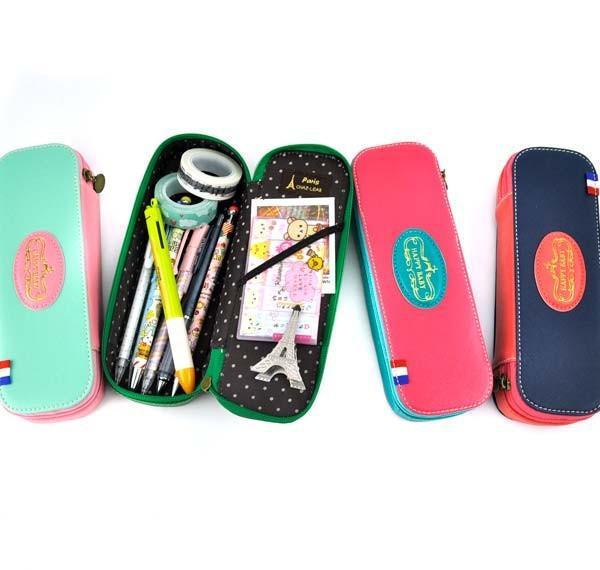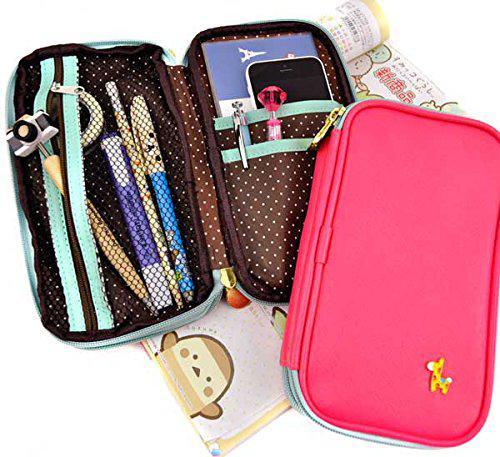The first image is the image on the left, the second image is the image on the right. Examine the images to the left and right. Is the description "The left image shows exactly four pencil cases on a white background." accurate? Answer yes or no. Yes. The first image is the image on the left, the second image is the image on the right. Considering the images on both sides, is "In one image, a rectangular shaped case is shown in four different colors." valid? Answer yes or no. Yes. 